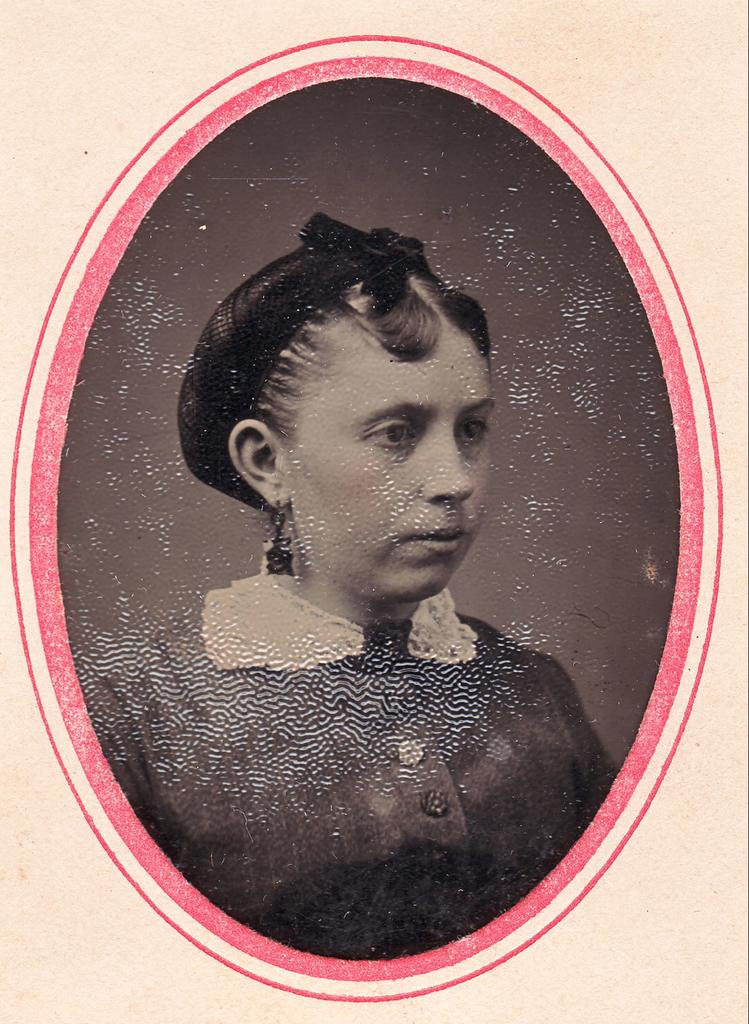What is present in the image that is related to visual art? There is a poster in the image. What object is present in the image that might be used to display the poster? There is a frame in the image. Who is the main subject in the image? There is a woman in the middle of the image. What type of silk fabric is draped over the woman's shoulders in the image? There is no silk fabric present in the image; the woman is not wearing any clothing or accessories made of silk. 